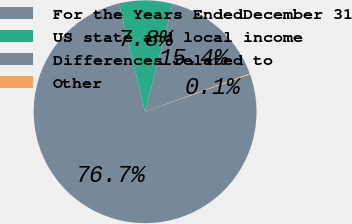Convert chart to OTSL. <chart><loc_0><loc_0><loc_500><loc_500><pie_chart><fcel>For the Years EndedDecember 31<fcel>US state and local income<fcel>Differences related to<fcel>Other<nl><fcel>76.68%<fcel>7.77%<fcel>15.43%<fcel>0.12%<nl></chart> 